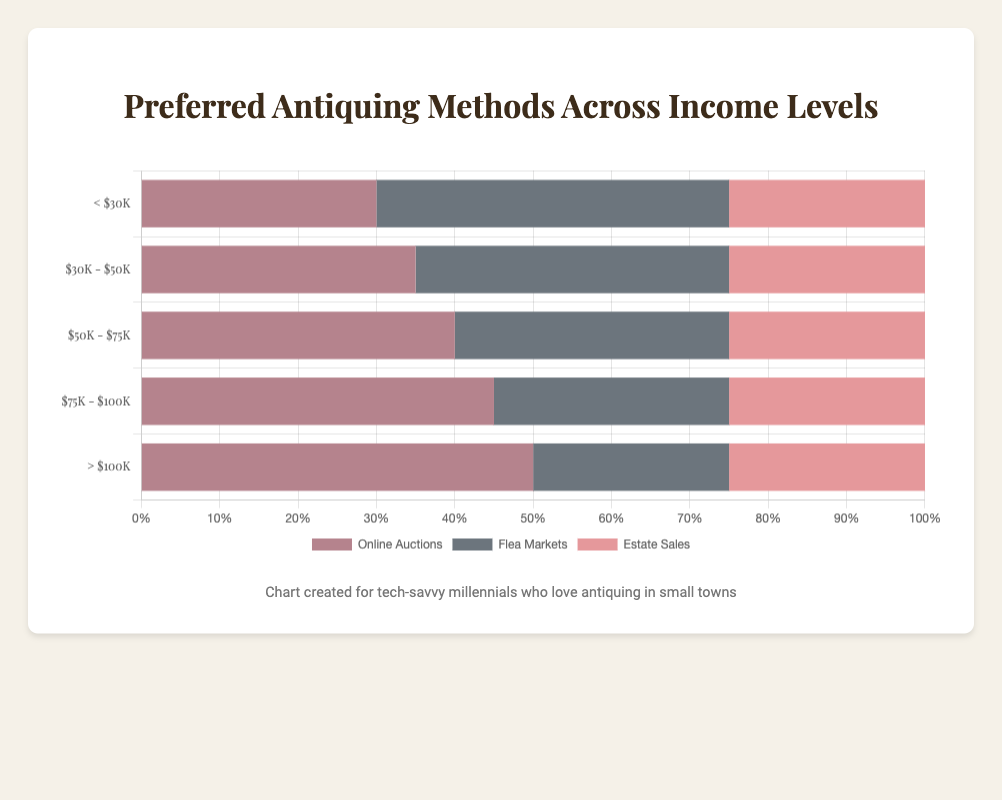Which income level has the highest preference for Online Auctions? By observing the horizontal bars for Online Auctions, identify the longest bar. This bar corresponds to the highest value, which is for the '> $100K' income level at 50%.
Answer: '> $100K' How does the preference for Flea Markets change as income increases from '< $30K' to '> $100K'? Compare the lengths of the horizontal bars for Flea Markets across each income level. As income increases, the preference decreases from 45% (< $30K) to 25% (> $100K).
Answer: Decreases What is the most preferred antiquing method for the '$50K - $75K' income level? Examine the length of the horizontal bars in the '$50K - $75K' range. The longest bar is for Online Auctions at 40%.
Answer: Online Auctions Which income level shows an equal preference for Estate Sales and Online Auctions? Look for the income level where the bars for Estate Sales and Online Auctions are of the same length. However, there is no income level where these preferences are equal.
Answer: None Calculate the total preference percentage for Flea Markets across all income levels. Sum the percentages for Flea Markets across each income level: 45 + 40 + 35 + 30 + 25 = 175%.
Answer: 175% Which income level has the smallest difference between preferences for Flea Markets and Online Auctions? Calculate the difference for each income level: 
< $30K: 45 - 30 = 15 
$30K - $50K: 40 - 35 = 5 
$50K - $75K: 35 - 40 = 5 
$75K - $100K: 30 - 45 = 15 
> $100K: 25 - 50 = 25 
Income levels '$30K - $50K' and '$50K - $75K' have the smallest differences of 5.
Answer: $30K - $50K and $50K - $75K Which antiquing method is the least preferred overall? Sum the percentages for each method across all income levels: 
Online Auctions: 30 + 35 + 40 + 45 + 50 = 200% 
Flea Markets: 45 + 40 + 35 + 30 + 25 = 175% 
Estate Sales: 25 + 25 + 25 + 25 + 25 = 125% 
Estate Sales has the lowest sum.
Answer: Estate Sales What is the difference in preference for Online Auctions between the '< $30K' and '> $100K' income levels? Subtract the preference percentage of '< $30K' for Online Auctions from '> $100K': 50 - 30 = 20%.
Answer: 20% What is the average preference percentage for Estate Sales across all income levels? The preference percentage for Estate Sales is consistently 25% across all income levels. Therefore, the average is 25%.
Answer: 25% What pattern can you observe in the preference for Online Auctions as income levels increase? As income increases from '< $30K' to '> $100K', the preference for Online Auctions consistently increases in 5% increments.
Answer: Increasing increments 